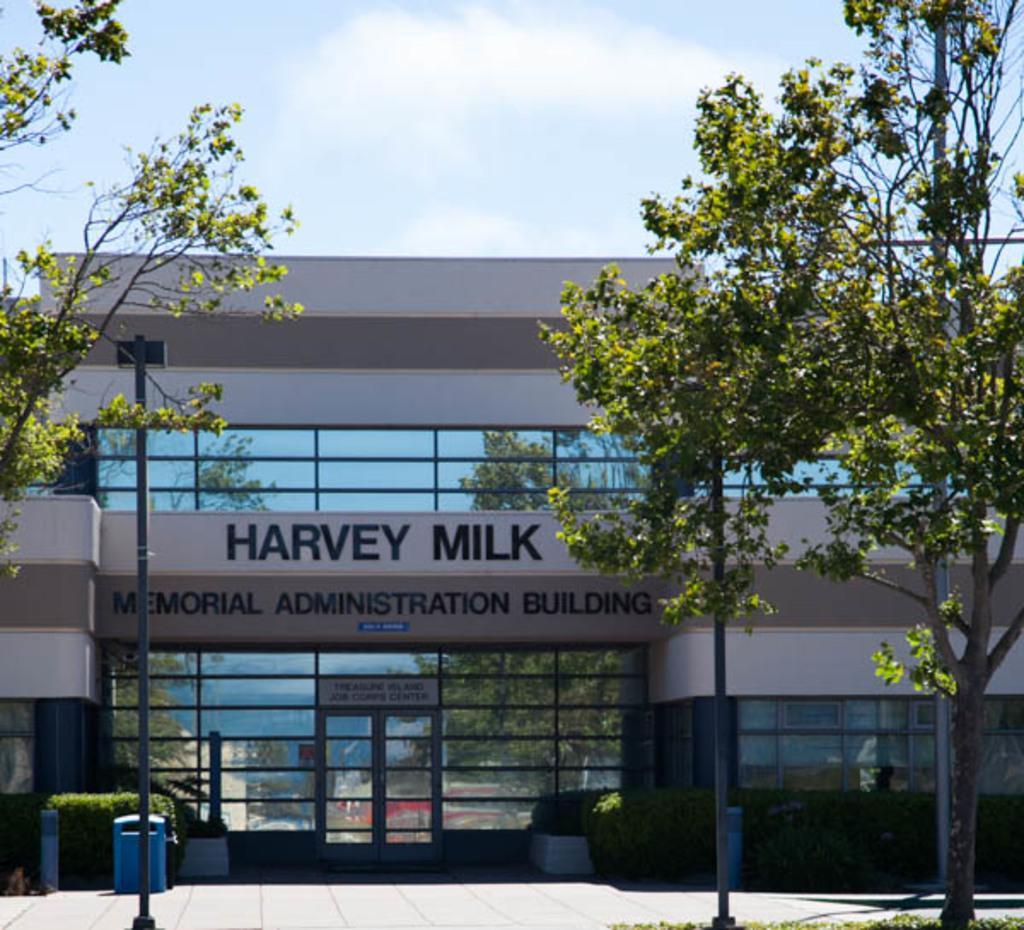Could you give a brief overview of what you see in this image? In this picture we can see poles, trees, bushes and a building and to the building there is a door and behind the building there is a sky. 